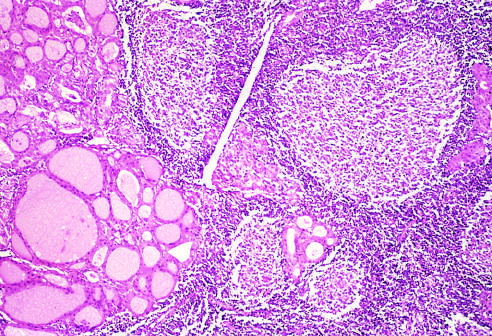re residual thyroid follicles lined by deeply eosinophilic hurthle cells seen?
Answer the question using a single word or phrase. Yes 